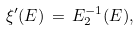<formula> <loc_0><loc_0><loc_500><loc_500>\xi ^ { \prime } ( E ) \, = \, E _ { 2 } ^ { - 1 } ( E ) ,</formula> 